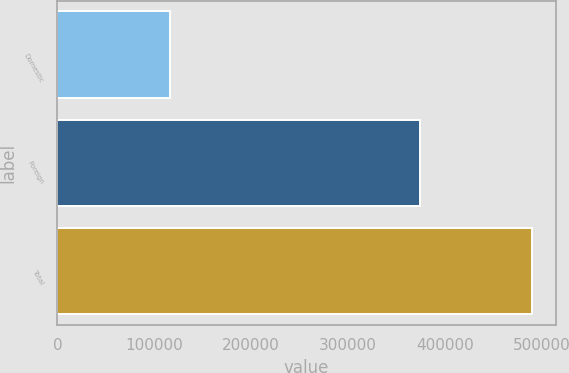Convert chart. <chart><loc_0><loc_0><loc_500><loc_500><bar_chart><fcel>Domestic<fcel>Foreign<fcel>Total<nl><fcel>116067<fcel>374038<fcel>490105<nl></chart> 